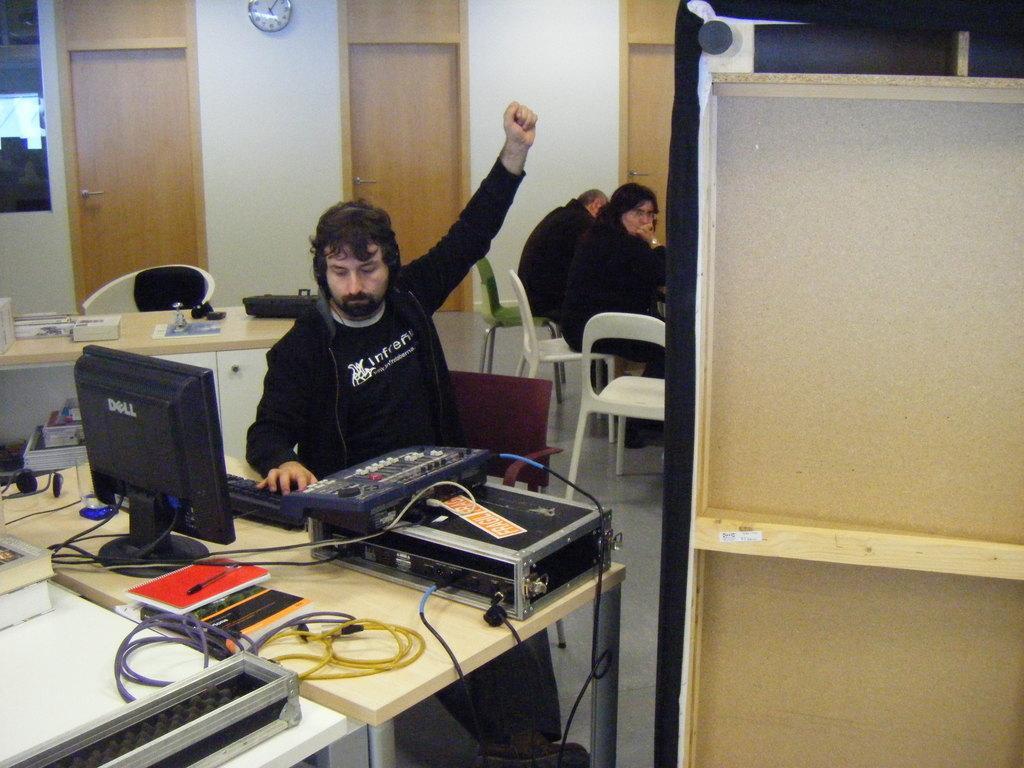How would you summarize this image in a sentence or two? In this image In the middle there is a man he wear black jacket, t shirt he is sitting on the chair, In front of him there is a table on that there is monitor, keyboard, some other items. In the back ground there are some people,chairs, door, clock and wall. 